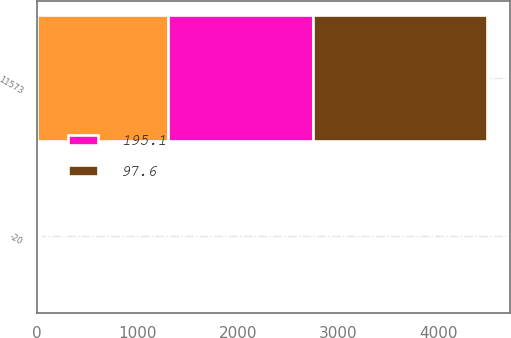Convert chart. <chart><loc_0><loc_0><loc_500><loc_500><stacked_bar_chart><ecel><fcel>-20<fcel>11573<nl><fcel>nan<fcel>10<fcel>1302<nl><fcel>195.1<fcel>0<fcel>1446.7<nl><fcel>97.6<fcel>20<fcel>1736<nl></chart> 